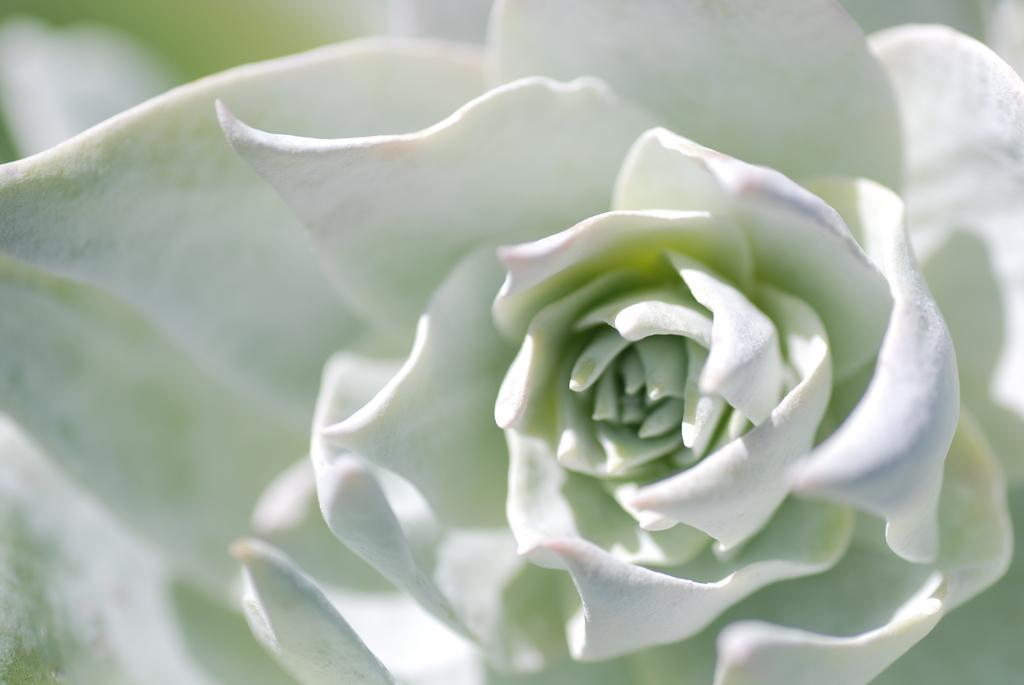What is the main subject in the foreground of the image? There is a flower in the foreground of the image. What color is the flower? The flower is white in color. How many fingers can be seen holding the flower in the image? There are no fingers visible in the image, as it only features a white flower in the foreground. 